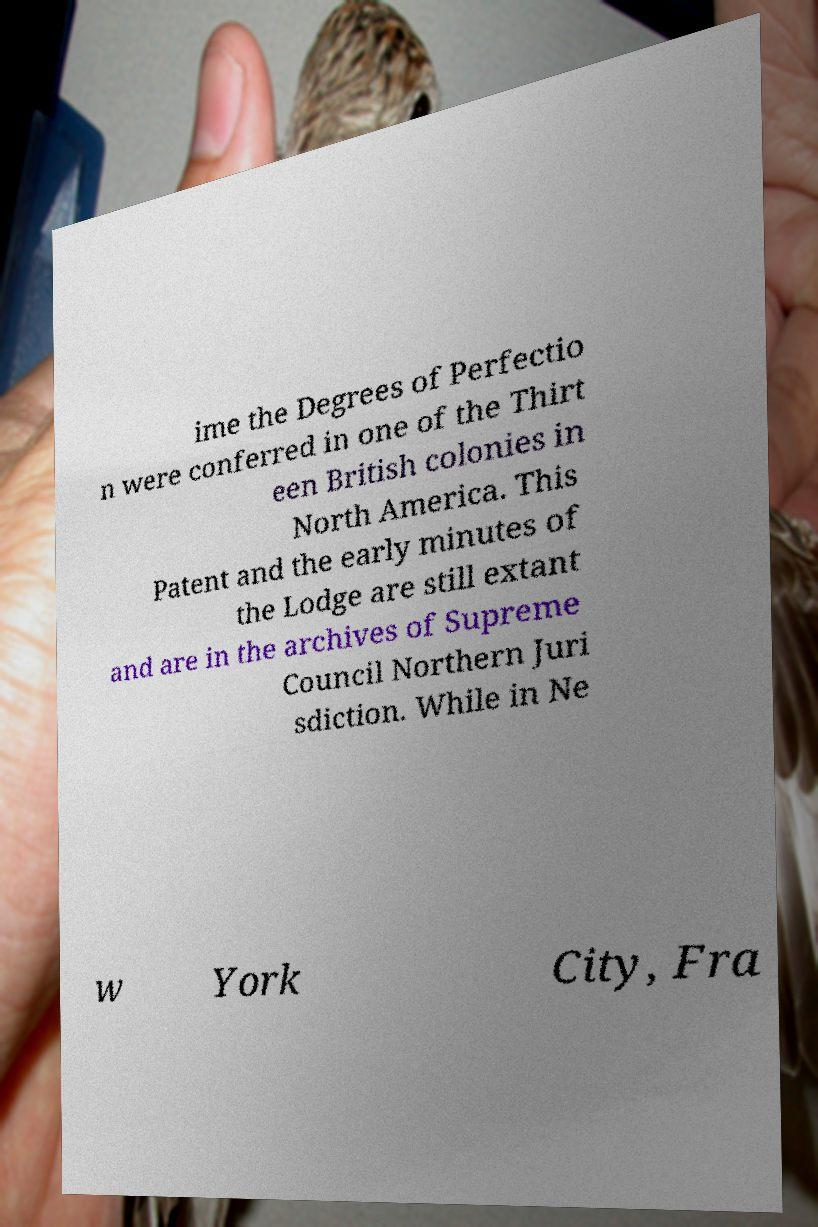Can you accurately transcribe the text from the provided image for me? ime the Degrees of Perfectio n were conferred in one of the Thirt een British colonies in North America. This Patent and the early minutes of the Lodge are still extant and are in the archives of Supreme Council Northern Juri sdiction. While in Ne w York City, Fra 